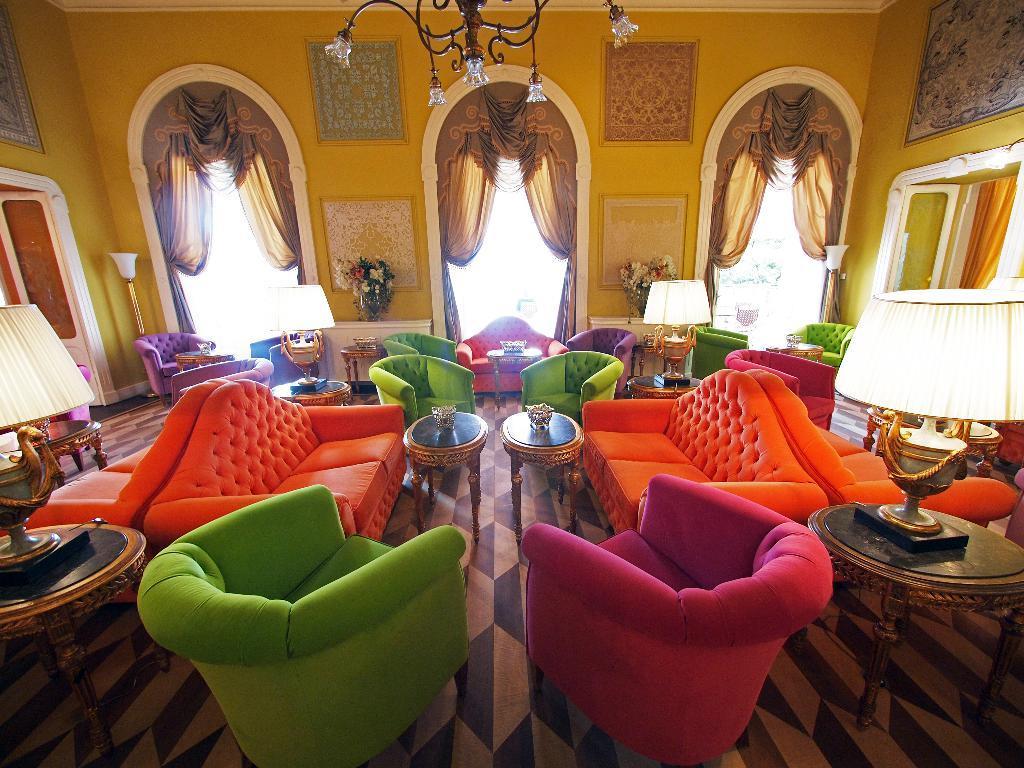In one or two sentences, can you explain what this image depicts? In this image I can see number of sofas in different colors. I can also see few tables, lamps, flowers and curtains. 